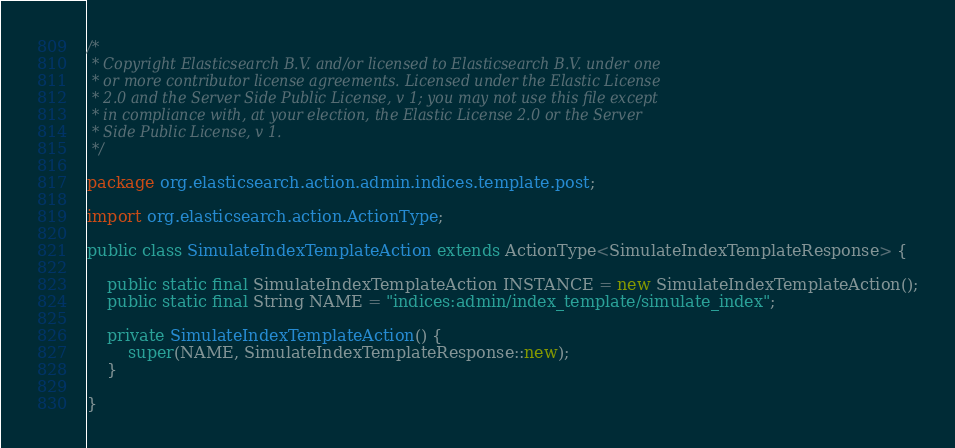Convert code to text. <code><loc_0><loc_0><loc_500><loc_500><_Java_>/*
 * Copyright Elasticsearch B.V. and/or licensed to Elasticsearch B.V. under one
 * or more contributor license agreements. Licensed under the Elastic License
 * 2.0 and the Server Side Public License, v 1; you may not use this file except
 * in compliance with, at your election, the Elastic License 2.0 or the Server
 * Side Public License, v 1.
 */

package org.elasticsearch.action.admin.indices.template.post;

import org.elasticsearch.action.ActionType;

public class SimulateIndexTemplateAction extends ActionType<SimulateIndexTemplateResponse> {

    public static final SimulateIndexTemplateAction INSTANCE = new SimulateIndexTemplateAction();
    public static final String NAME = "indices:admin/index_template/simulate_index";

    private SimulateIndexTemplateAction() {
        super(NAME, SimulateIndexTemplateResponse::new);
    }

}
</code> 